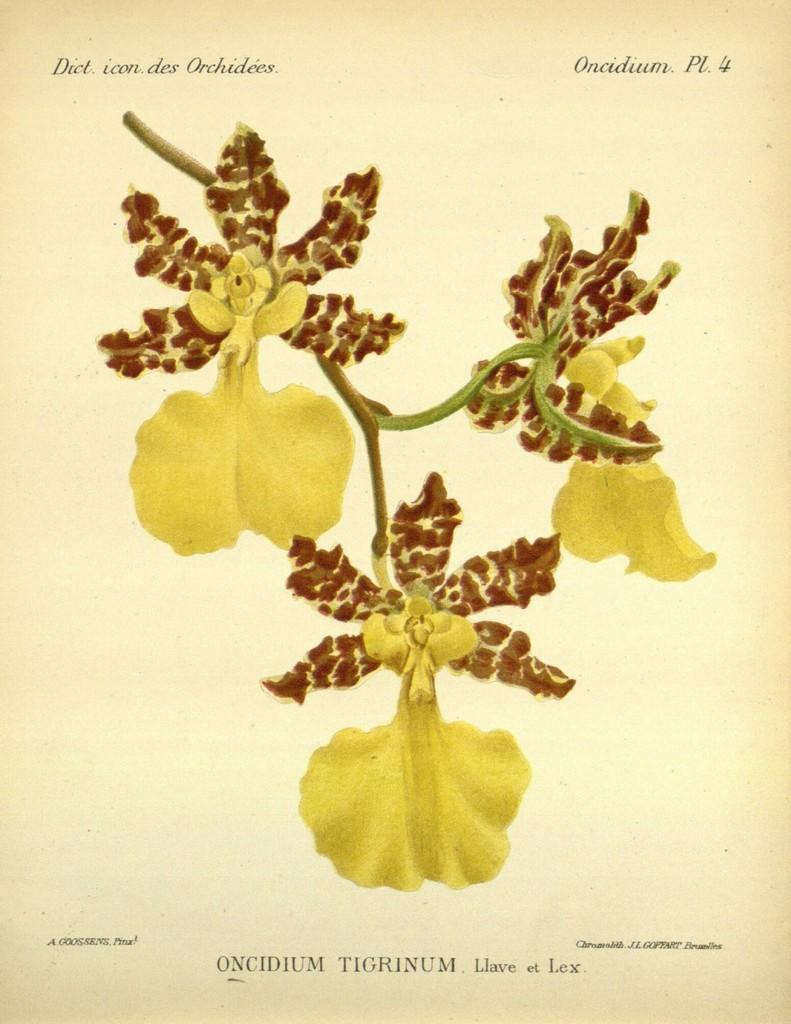Provide a one-sentence caption for the provided image. A poster of yellow flowers that says Oncidium Pl 4 on it. 